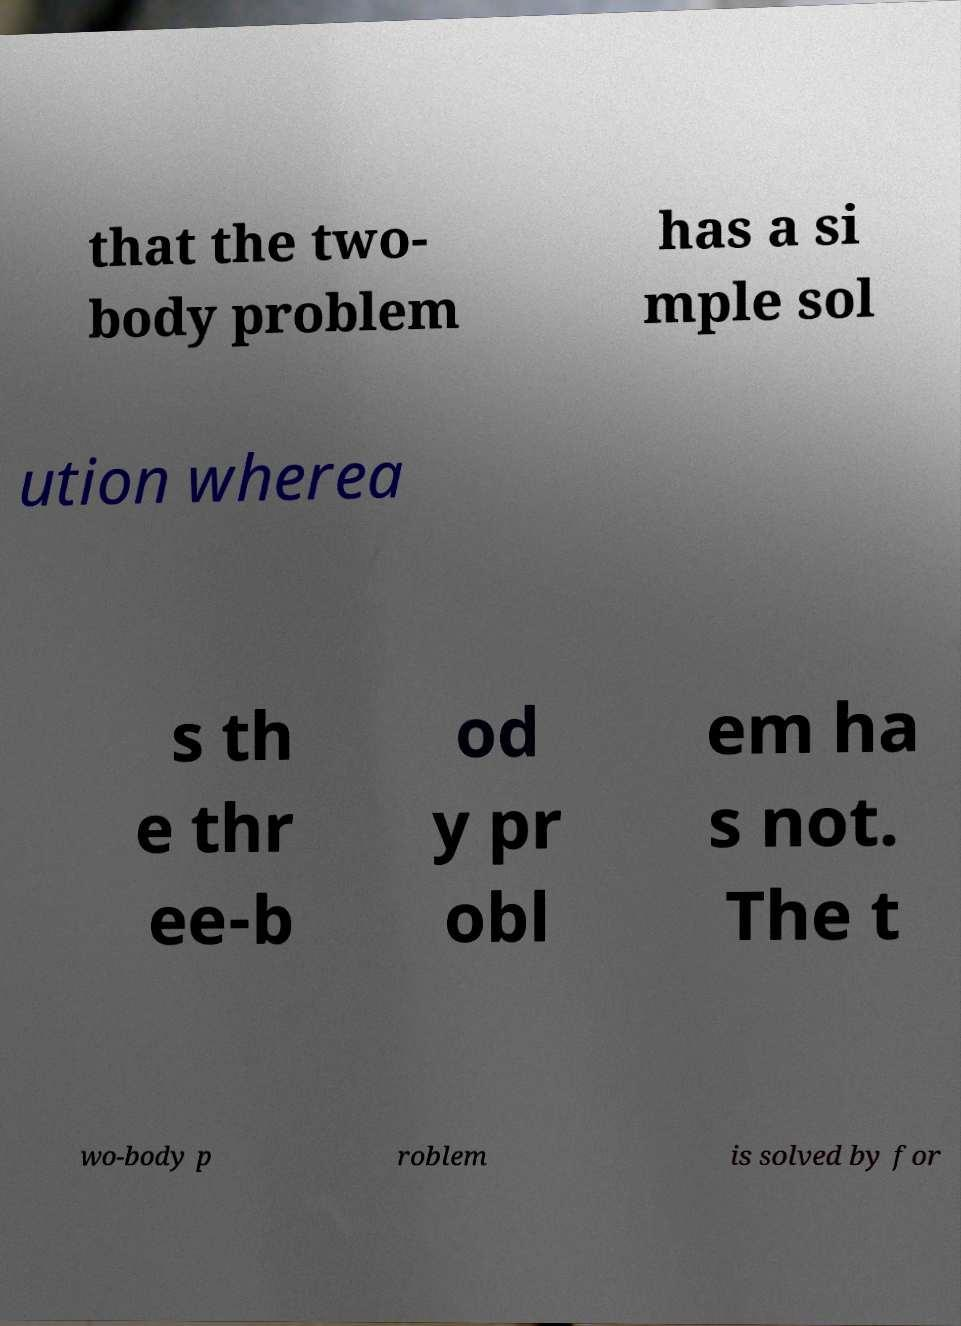Could you extract and type out the text from this image? that the two- body problem has a si mple sol ution wherea s th e thr ee-b od y pr obl em ha s not. The t wo-body p roblem is solved by for 